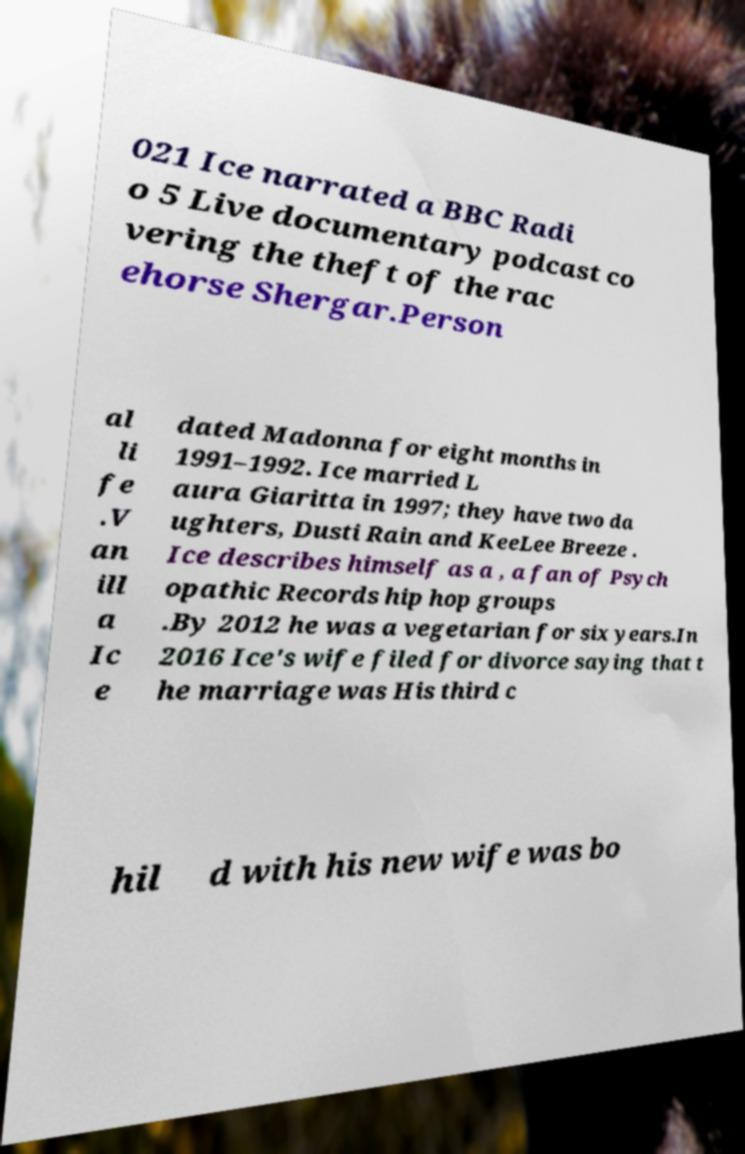What messages or text are displayed in this image? I need them in a readable, typed format. 021 Ice narrated a BBC Radi o 5 Live documentary podcast co vering the theft of the rac ehorse Shergar.Person al li fe .V an ill a Ic e dated Madonna for eight months in 1991–1992. Ice married L aura Giaritta in 1997; they have two da ughters, Dusti Rain and KeeLee Breeze . Ice describes himself as a , a fan of Psych opathic Records hip hop groups .By 2012 he was a vegetarian for six years.In 2016 Ice's wife filed for divorce saying that t he marriage was His third c hil d with his new wife was bo 